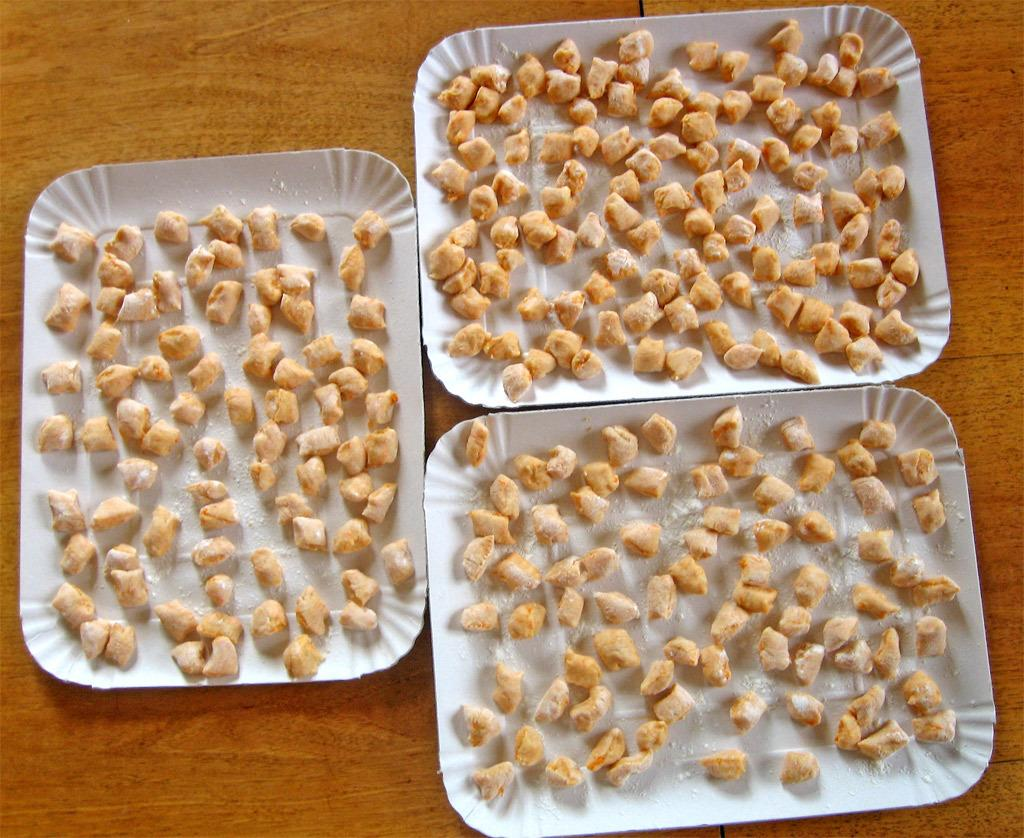What is present on the table in the image? There is a table in the image. What items are on the table? There are three trays of sweets on the table. What type of lettuce can be seen on the table in the image? There is no lettuce present on the table in the image; it only features three trays of sweets. 